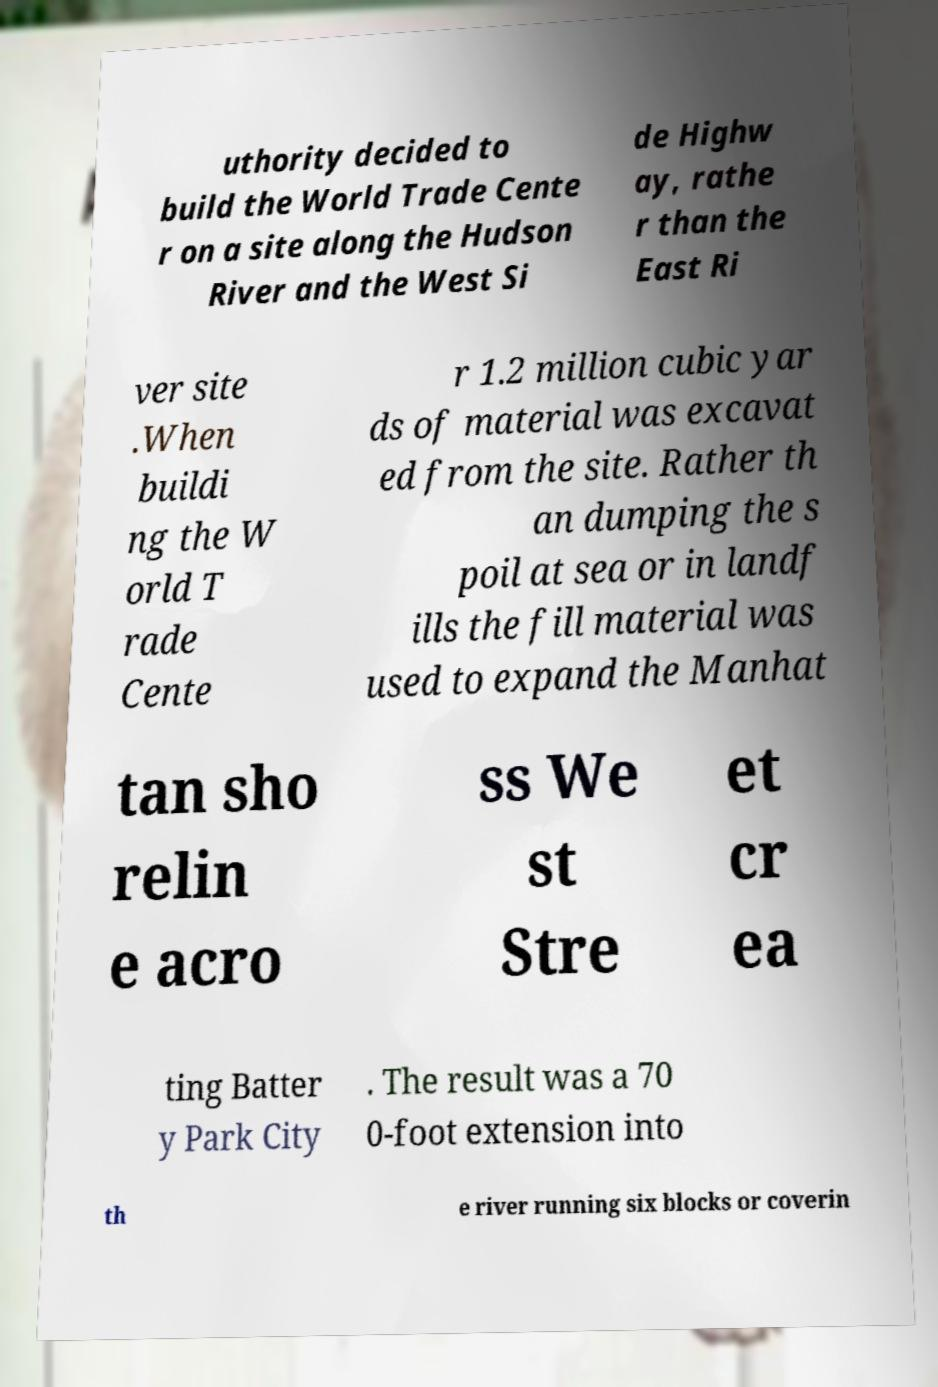Please read and relay the text visible in this image. What does it say? uthority decided to build the World Trade Cente r on a site along the Hudson River and the West Si de Highw ay, rathe r than the East Ri ver site .When buildi ng the W orld T rade Cente r 1.2 million cubic yar ds of material was excavat ed from the site. Rather th an dumping the s poil at sea or in landf ills the fill material was used to expand the Manhat tan sho relin e acro ss We st Stre et cr ea ting Batter y Park City . The result was a 70 0-foot extension into th e river running six blocks or coverin 